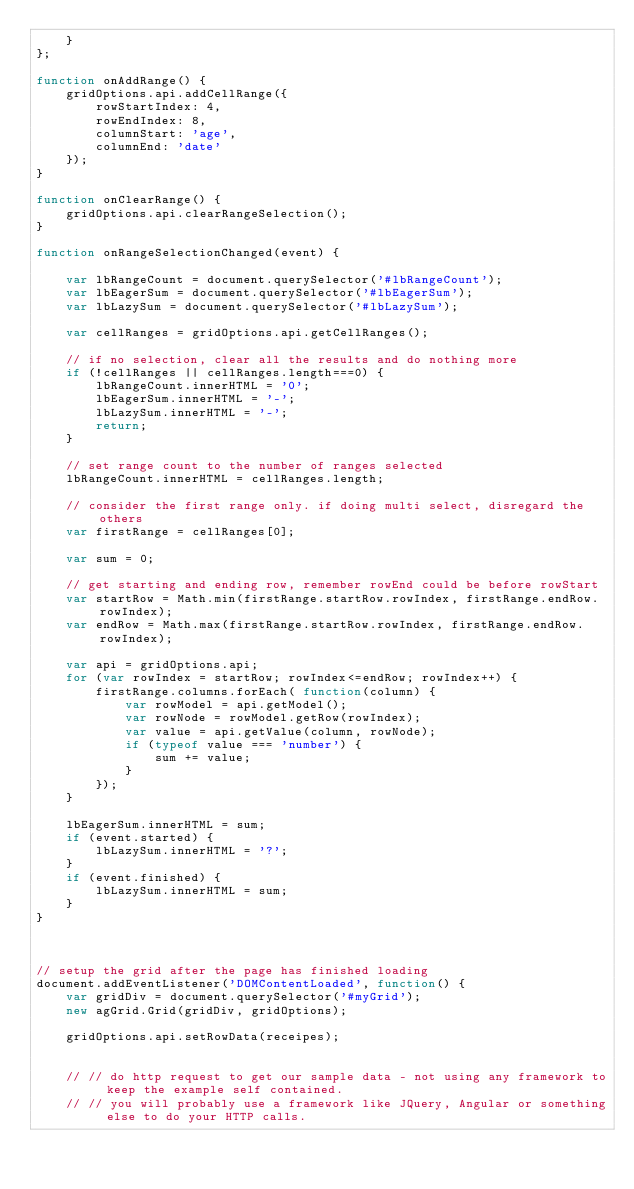<code> <loc_0><loc_0><loc_500><loc_500><_JavaScript_>    }
};

function onAddRange() {
    gridOptions.api.addCellRange({
        rowStartIndex: 4,
        rowEndIndex: 8,
        columnStart: 'age',
        columnEnd: 'date'
    });
}

function onClearRange() {
    gridOptions.api.clearRangeSelection();
}

function onRangeSelectionChanged(event) {

    var lbRangeCount = document.querySelector('#lbRangeCount');
    var lbEagerSum = document.querySelector('#lbEagerSum');
    var lbLazySum = document.querySelector('#lbLazySum');

    var cellRanges = gridOptions.api.getCellRanges();

    // if no selection, clear all the results and do nothing more
    if (!cellRanges || cellRanges.length===0) {
        lbRangeCount.innerHTML = '0';
        lbEagerSum.innerHTML = '-';
        lbLazySum.innerHTML = '-';
        return;
    }

    // set range count to the number of ranges selected
    lbRangeCount.innerHTML = cellRanges.length;

    // consider the first range only. if doing multi select, disregard the others
    var firstRange = cellRanges[0];

    var sum = 0;

    // get starting and ending row, remember rowEnd could be before rowStart
    var startRow = Math.min(firstRange.startRow.rowIndex, firstRange.endRow.rowIndex);
    var endRow = Math.max(firstRange.startRow.rowIndex, firstRange.endRow.rowIndex);

    var api = gridOptions.api;
    for (var rowIndex = startRow; rowIndex<=endRow; rowIndex++) {
        firstRange.columns.forEach( function(column) {
            var rowModel = api.getModel();
            var rowNode = rowModel.getRow(rowIndex);
            var value = api.getValue(column, rowNode);
            if (typeof value === 'number') {
                sum += value;
            }
        });
    }

    lbEagerSum.innerHTML = sum;
    if (event.started) {
        lbLazySum.innerHTML = '?';
    }
    if (event.finished) {
        lbLazySum.innerHTML = sum;
    }
}



// setup the grid after the page has finished loading
document.addEventListener('DOMContentLoaded', function() {
    var gridDiv = document.querySelector('#myGrid');
    new agGrid.Grid(gridDiv, gridOptions);

    gridOptions.api.setRowData(receipes);


    // // do http request to get our sample data - not using any framework to keep the example self contained.
    // // you will probably use a framework like JQuery, Angular or something else to do your HTTP calls.</code> 